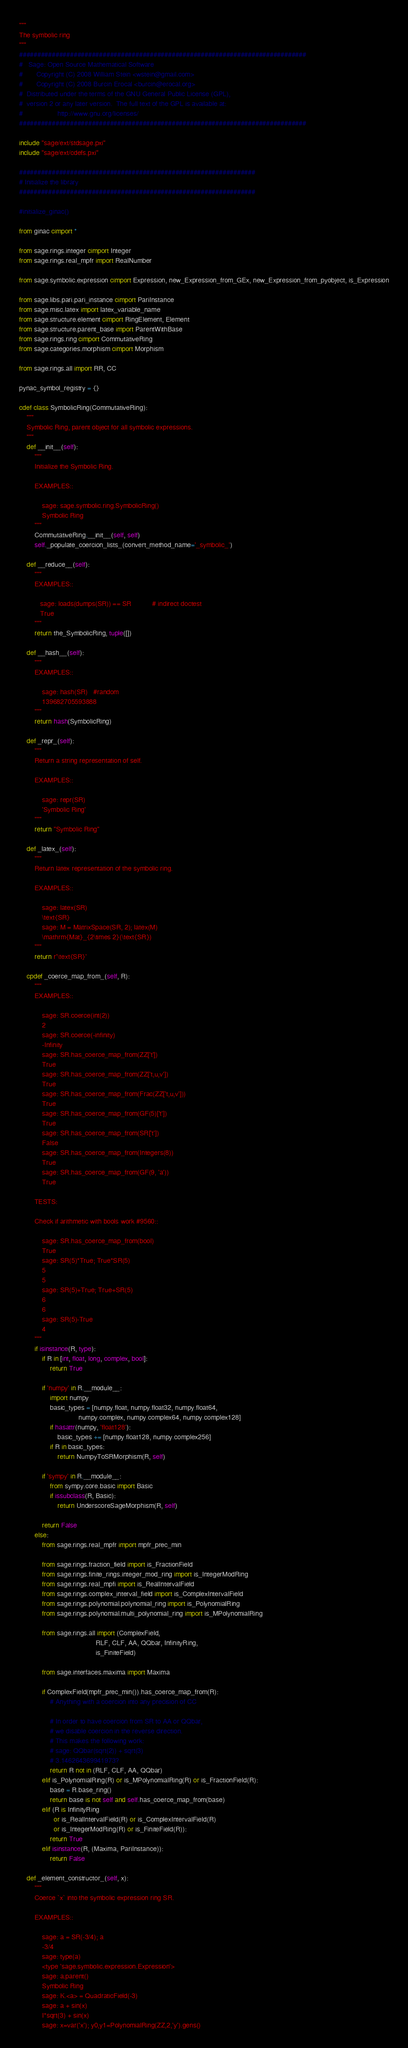Convert code to text. <code><loc_0><loc_0><loc_500><loc_500><_Cython_>"""
The symbolic ring
"""
###############################################################################
#   Sage: Open Source Mathematical Software
#       Copyright (C) 2008 William Stein <wstein@gmail.com>
#       Copyright (C) 2008 Burcin Erocal <burcin@erocal.org>
#  Distributed under the terms of the GNU General Public License (GPL),
#  version 2 or any later version.  The full text of the GPL is available at:
#                  http://www.gnu.org/licenses/
###############################################################################

include "sage/ext/stdsage.pxi"
include "sage/ext/cdefs.pxi"

#################################################################
# Initialize the library
#################################################################

#initialize_ginac()

from ginac cimport *

from sage.rings.integer cimport Integer
from sage.rings.real_mpfr import RealNumber

from sage.symbolic.expression cimport Expression, new_Expression_from_GEx, new_Expression_from_pyobject, is_Expression

from sage.libs.pari.pari_instance cimport PariInstance
from sage.misc.latex import latex_variable_name
from sage.structure.element cimport RingElement, Element
from sage.structure.parent_base import ParentWithBase
from sage.rings.ring cimport CommutativeRing
from sage.categories.morphism cimport Morphism

from sage.rings.all import RR, CC

pynac_symbol_registry = {}

cdef class SymbolicRing(CommutativeRing):
    """
    Symbolic Ring, parent object for all symbolic expressions.
    """
    def __init__(self):
        """
        Initialize the Symbolic Ring.

        EXAMPLES::

            sage: sage.symbolic.ring.SymbolicRing()
            Symbolic Ring
        """
        CommutativeRing.__init__(self, self)
        self._populate_coercion_lists_(convert_method_name='_symbolic_')

    def __reduce__(self):
        """
        EXAMPLES::

           sage: loads(dumps(SR)) == SR           # indirect doctest
           True
        """
        return the_SymbolicRing, tuple([])

    def __hash__(self):
        """
        EXAMPLES::

            sage: hash(SR)   #random
            139682705593888
        """
        return hash(SymbolicRing)

    def _repr_(self):
        """
        Return a string representation of self.

        EXAMPLES::

            sage: repr(SR)
            'Symbolic Ring'
        """
        return "Symbolic Ring"

    def _latex_(self):
        """
        Return latex representation of the symbolic ring.

        EXAMPLES::

            sage: latex(SR)
            \text{SR}
            sage: M = MatrixSpace(SR, 2); latex(M)
            \mathrm{Mat}_{2\times 2}(\text{SR})
        """
        return r'\text{SR}'

    cpdef _coerce_map_from_(self, R):
        """
        EXAMPLES::

            sage: SR.coerce(int(2))
            2
            sage: SR.coerce(-infinity)
            -Infinity
            sage: SR.has_coerce_map_from(ZZ['t'])
            True
            sage: SR.has_coerce_map_from(ZZ['t,u,v'])
            True
            sage: SR.has_coerce_map_from(Frac(ZZ['t,u,v']))
            True
            sage: SR.has_coerce_map_from(GF(5)['t'])
            True
            sage: SR.has_coerce_map_from(SR['t'])
            False
            sage: SR.has_coerce_map_from(Integers(8))
            True
            sage: SR.has_coerce_map_from(GF(9, 'a'))
            True

        TESTS:

        Check if arithmetic with bools work #9560::

            sage: SR.has_coerce_map_from(bool)
            True
            sage: SR(5)*True; True*SR(5)
            5
            5
            sage: SR(5)+True; True+SR(5)
            6
            6
            sage: SR(5)-True
            4
        """
        if isinstance(R, type):
            if R in [int, float, long, complex, bool]:
                return True

            if 'numpy' in R.__module__:
                import numpy
                basic_types = [numpy.float, numpy.float32, numpy.float64,
                               numpy.complex, numpy.complex64, numpy.complex128]
                if hasattr(numpy, 'float128'):
                    basic_types += [numpy.float128, numpy.complex256]
                if R in basic_types:
                    return NumpyToSRMorphism(R, self)

            if 'sympy' in R.__module__:
                from sympy.core.basic import Basic
                if issubclass(R, Basic):
                    return UnderscoreSageMorphism(R, self)

            return False
        else:
            from sage.rings.real_mpfr import mpfr_prec_min

            from sage.rings.fraction_field import is_FractionField
            from sage.rings.finite_rings.integer_mod_ring import is_IntegerModRing
            from sage.rings.real_mpfi import is_RealIntervalField
            from sage.rings.complex_interval_field import is_ComplexIntervalField
            from sage.rings.polynomial.polynomial_ring import is_PolynomialRing
            from sage.rings.polynomial.multi_polynomial_ring import is_MPolynomialRing

            from sage.rings.all import (ComplexField,
                                        RLF, CLF, AA, QQbar, InfinityRing,
                                        is_FiniteField)

            from sage.interfaces.maxima import Maxima

            if ComplexField(mpfr_prec_min()).has_coerce_map_from(R):
                # Anything with a coercion into any precision of CC

                # In order to have coercion from SR to AA or QQbar,
                # we disable coercion in the reverse direction.
                # This makes the following work:
                # sage: QQbar(sqrt(2)) + sqrt(3)
                # 3.146264369941973?
                return R not in (RLF, CLF, AA, QQbar)
            elif is_PolynomialRing(R) or is_MPolynomialRing(R) or is_FractionField(R):
                base = R.base_ring()
                return base is not self and self.has_coerce_map_from(base)
            elif (R is InfinityRing
                  or is_RealIntervalField(R) or is_ComplexIntervalField(R)
                  or is_IntegerModRing(R) or is_FiniteField(R)):
                return True
            elif isinstance(R, (Maxima, PariInstance)):
                return False

    def _element_constructor_(self, x):
        """
        Coerce `x` into the symbolic expression ring SR.

        EXAMPLES::

            sage: a = SR(-3/4); a
            -3/4
            sage: type(a)
            <type 'sage.symbolic.expression.Expression'>
            sage: a.parent()
            Symbolic Ring
            sage: K.<a> = QuadraticField(-3)
            sage: a + sin(x)
            I*sqrt(3) + sin(x)
            sage: x=var('x'); y0,y1=PolynomialRing(ZZ,2,'y').gens()</code> 